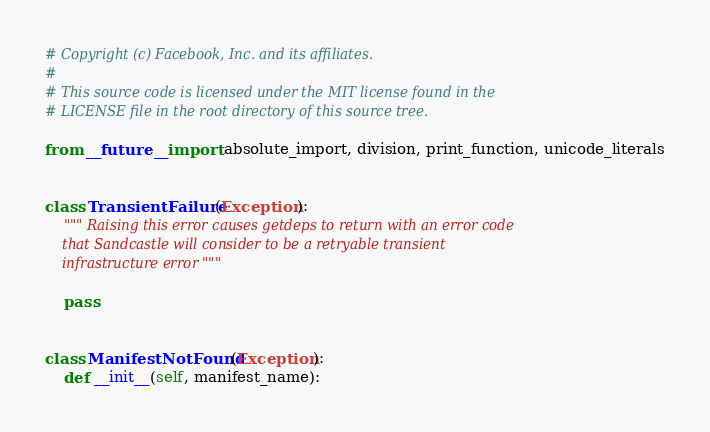<code> <loc_0><loc_0><loc_500><loc_500><_Python_># Copyright (c) Facebook, Inc. and its affiliates.
#
# This source code is licensed under the MIT license found in the
# LICENSE file in the root directory of this source tree.

from __future__ import absolute_import, division, print_function, unicode_literals


class TransientFailure(Exception):
    """ Raising this error causes getdeps to return with an error code
    that Sandcastle will consider to be a retryable transient
    infrastructure error """

    pass


class ManifestNotFound(Exception):
    def __init__(self, manifest_name):</code> 